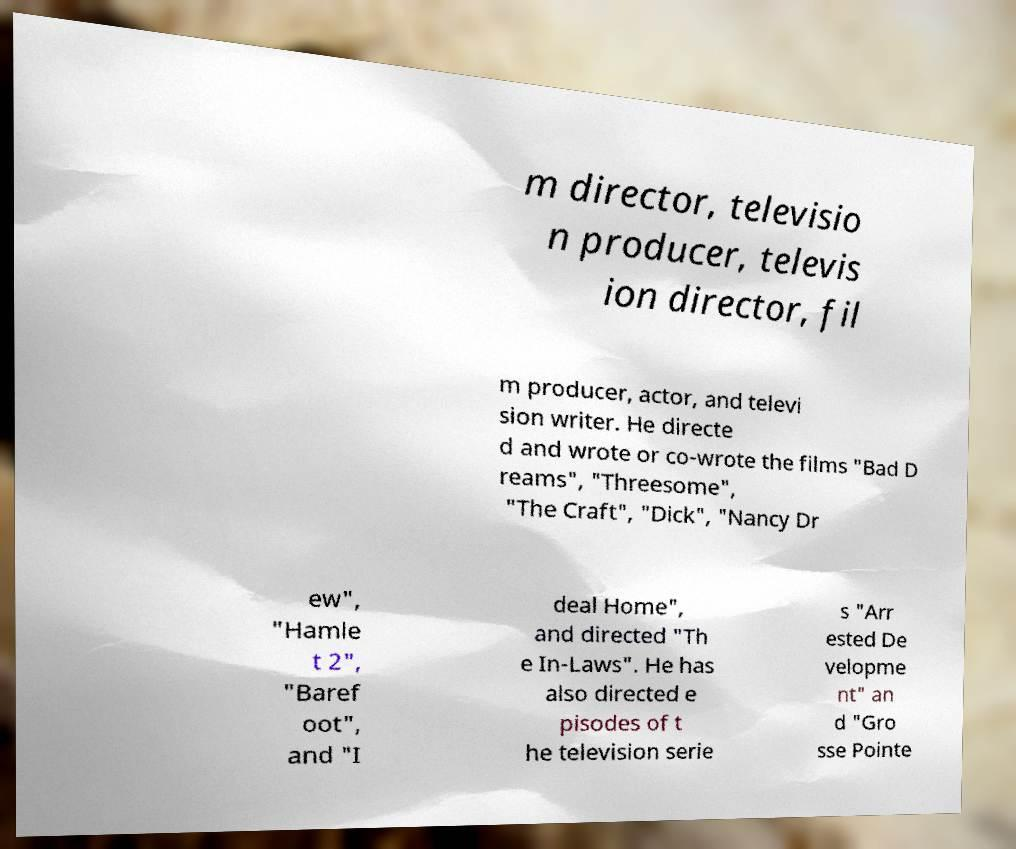I need the written content from this picture converted into text. Can you do that? m director, televisio n producer, televis ion director, fil m producer, actor, and televi sion writer. He directe d and wrote or co-wrote the films "Bad D reams", "Threesome", "The Craft", "Dick", "Nancy Dr ew", "Hamle t 2", "Baref oot", and "I deal Home", and directed "Th e In-Laws". He has also directed e pisodes of t he television serie s "Arr ested De velopme nt" an d "Gro sse Pointe 